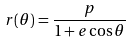<formula> <loc_0><loc_0><loc_500><loc_500>r ( \theta ) = \frac { p } { 1 + e \cos \theta }</formula> 